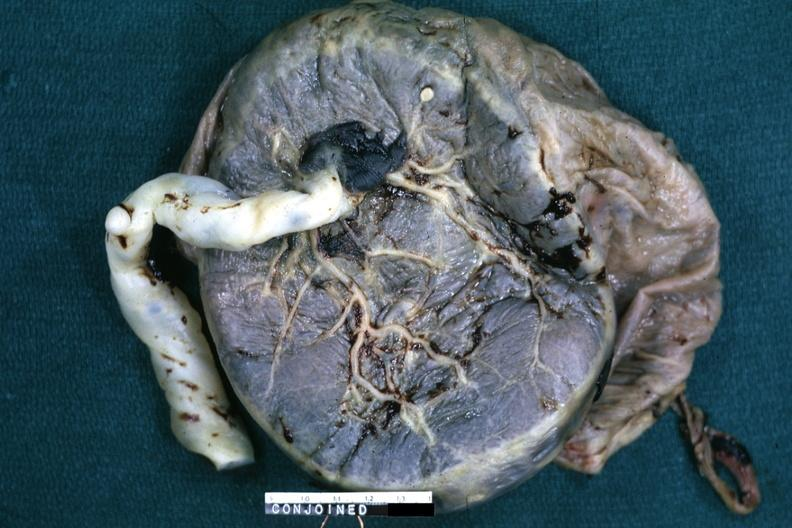what is present?
Answer the question using a single word or phrase. Siamese twins 